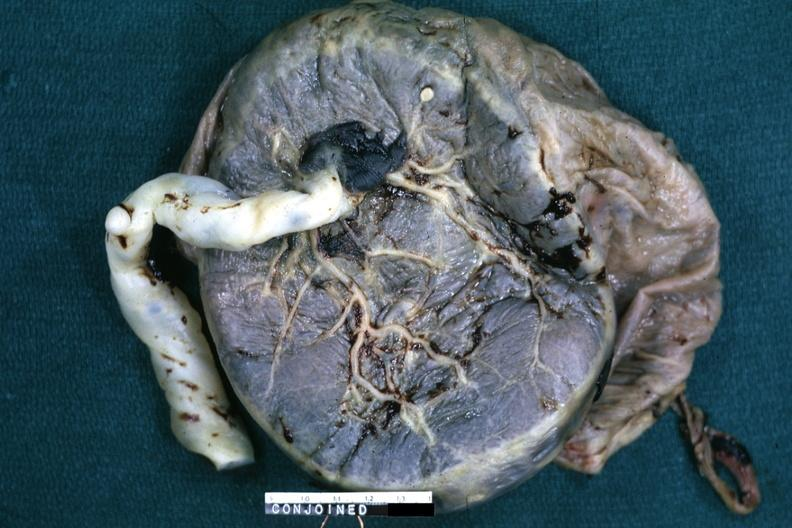what is present?
Answer the question using a single word or phrase. Siamese twins 